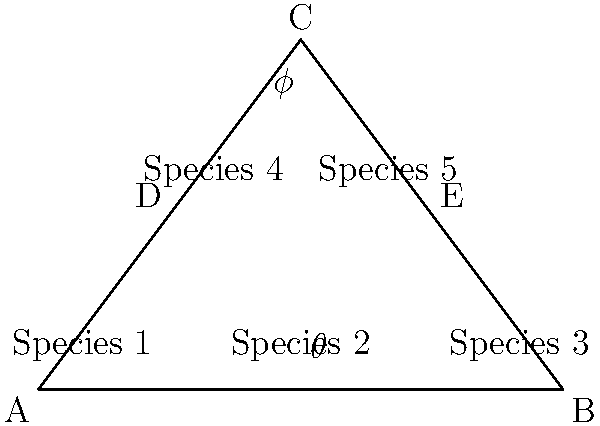In a phylogenetic tree representing the evolutionary relationships among five species, the branch point C forms two angles: $\theta$ at the base and $\phi$ at the top. If the horizontal distance between Species 1 and Species 3 is 6 units, and the vertical distance from the baseline to point C is 4 units, calculate the tangent of angle $\phi$. How does this value relate to the evolutionary divergence represented in the tree? To solve this problem, we'll follow these steps:

1) First, we need to identify the right triangle formed by the branch point C and the baseline. The base of this triangle spans half the total horizontal distance (6/2 = 3 units), and its height is 4 units.

2) The tangent of an angle is defined as the ratio of the opposite side to the adjacent side. For angle $\phi$:

   $\tan(\phi) = \frac{\text{opposite}}{\text{adjacent}} = \frac{\text{base of triangle}}{\text{height of triangle}}$

3) We can calculate this:

   $\tan(\phi) = \frac{3}{4} = 0.75$

4) In terms of evolutionary divergence:
   - The tangent represents the ratio of horizontal spread (representing time or genetic distance between species) to vertical distance (representing the accumulation of genetic changes).
   - A smaller tangent value (closer to 0) would indicate a steeper branch, suggesting rapid accumulation of genetic changes over a shorter evolutionary time.
   - A larger tangent value (closer to 1 or beyond) would indicate a more gradual branch, suggesting slower accumulation of genetic changes over a longer evolutionary time.

5) In this case, $\tan(\phi) = 0.75$ suggests a moderate rate of evolutionary divergence. The species have accumulated substantial genetic differences (represented by the vertical distance) over the evolutionary time represented by the horizontal distance.
Answer: $\tan(\phi) = 0.75$, indicating moderate evolutionary divergence rate 